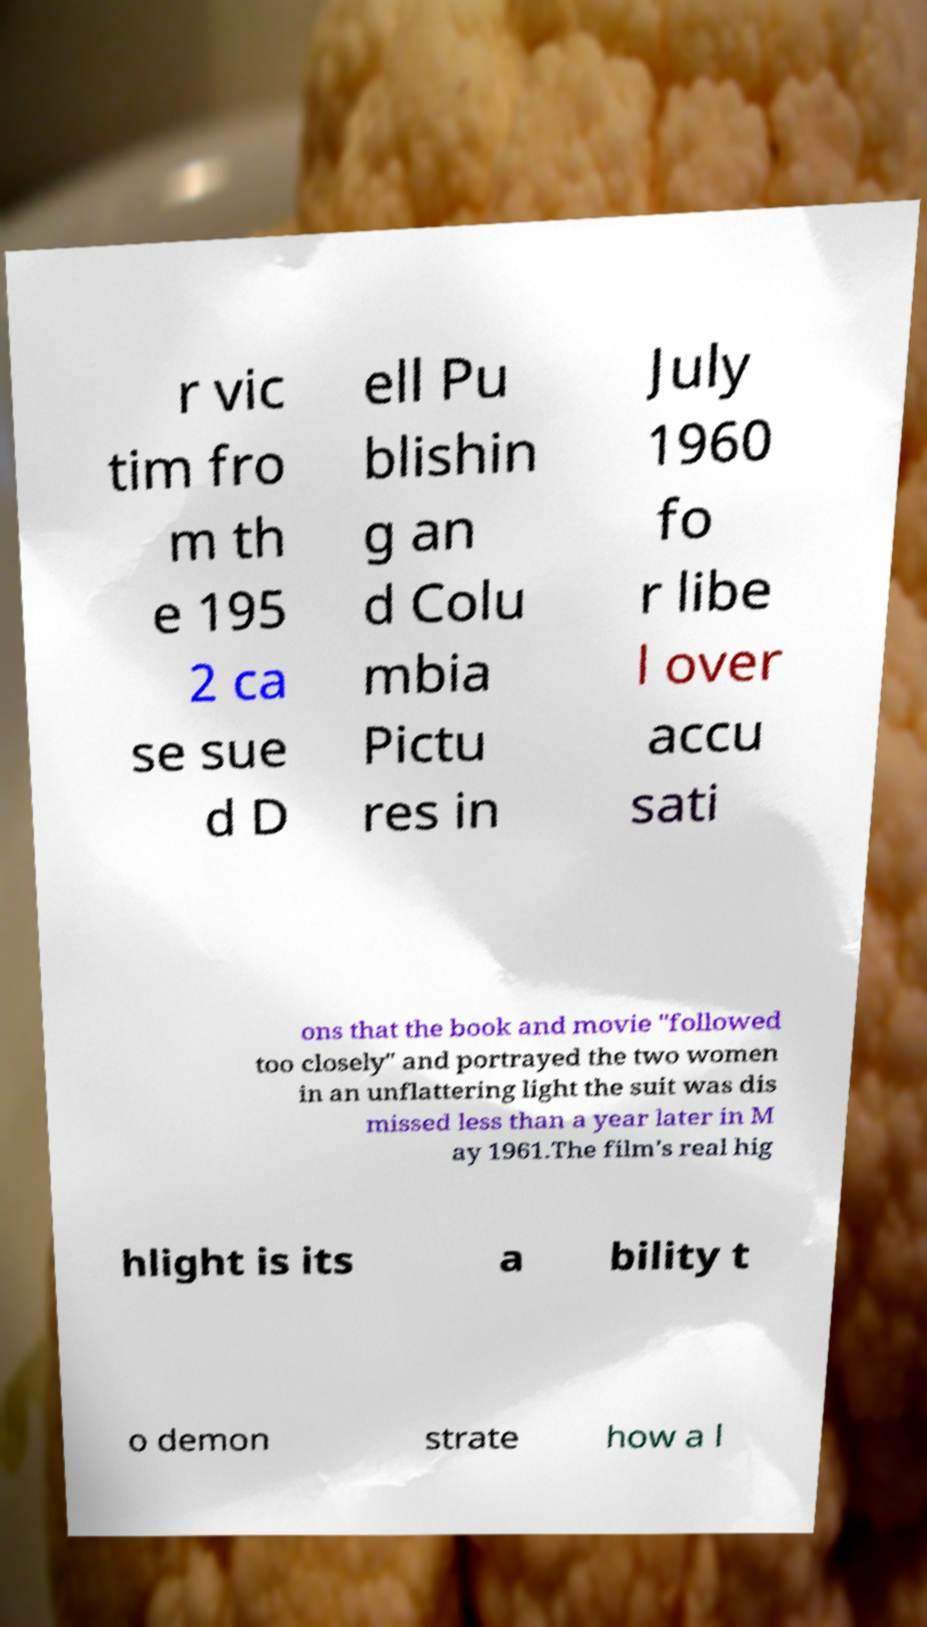I need the written content from this picture converted into text. Can you do that? r vic tim fro m th e 195 2 ca se sue d D ell Pu blishin g an d Colu mbia Pictu res in July 1960 fo r libe l over accu sati ons that the book and movie "followed too closely" and portrayed the two women in an unflattering light the suit was dis missed less than a year later in M ay 1961.The film's real hig hlight is its a bility t o demon strate how a l 